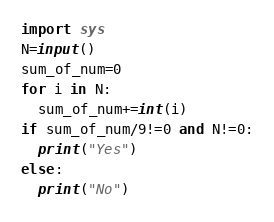<code> <loc_0><loc_0><loc_500><loc_500><_Python_>import sys
N=input()
sum_of_num=0
for i in N:
  sum_of_num+=int(i)
if sum_of_num/9!=0 and N!=0:
  print("Yes")
else:
  print("No")</code> 